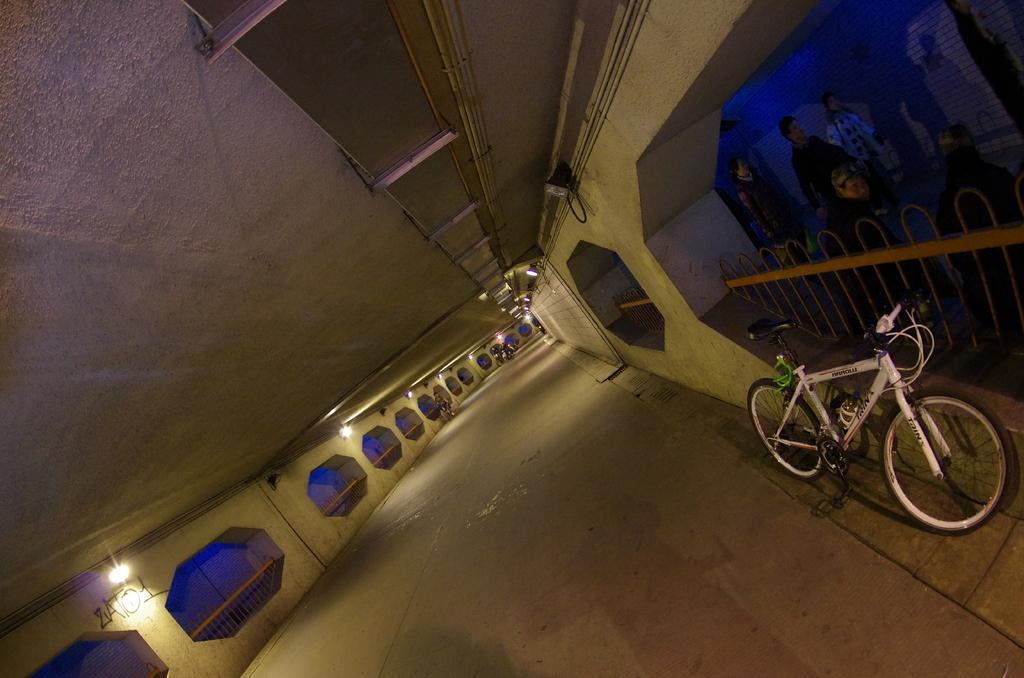What is the main object in the image? There is a bicycle in the image. Are there any people in the image? Yes, there are people in the image. What can be seen on both sides of the image? There is fencing on both sides of the image. What can be seen illuminating the scene? There are lights visible in the image. What else is present on top of the other objects? Other objects are present on top. How many dolls are holding hands in the image? There are no dolls present in the image, and therefore no dolls holding hands. 